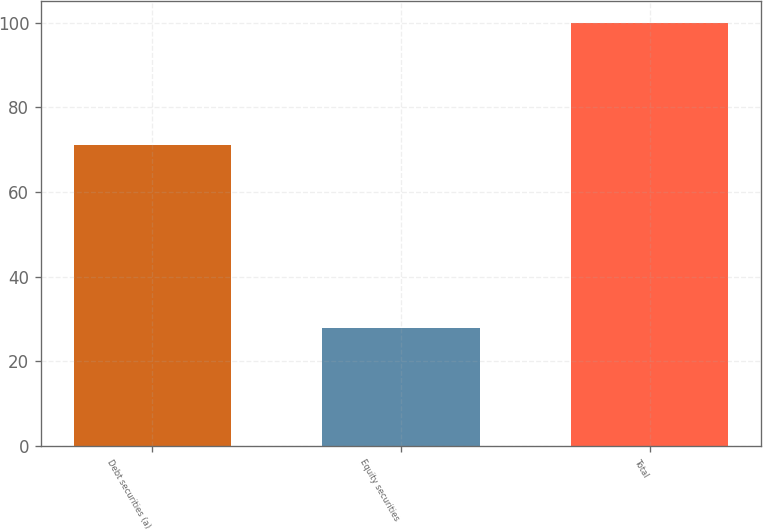Convert chart. <chart><loc_0><loc_0><loc_500><loc_500><bar_chart><fcel>Debt securities (a)<fcel>Equity securities<fcel>Total<nl><fcel>71<fcel>28<fcel>100<nl></chart> 